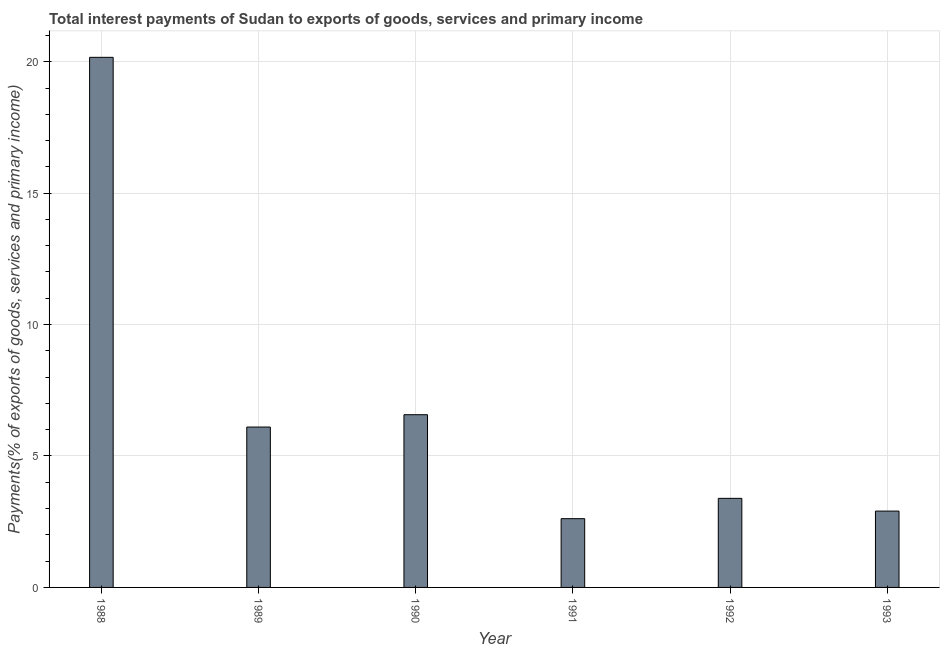Does the graph contain grids?
Offer a terse response. Yes. What is the title of the graph?
Provide a short and direct response. Total interest payments of Sudan to exports of goods, services and primary income. What is the label or title of the X-axis?
Offer a terse response. Year. What is the label or title of the Y-axis?
Your answer should be compact. Payments(% of exports of goods, services and primary income). What is the total interest payments on external debt in 1991?
Make the answer very short. 2.62. Across all years, what is the maximum total interest payments on external debt?
Offer a very short reply. 20.17. Across all years, what is the minimum total interest payments on external debt?
Provide a short and direct response. 2.62. In which year was the total interest payments on external debt maximum?
Provide a short and direct response. 1988. In which year was the total interest payments on external debt minimum?
Offer a terse response. 1991. What is the sum of the total interest payments on external debt?
Your answer should be very brief. 41.75. What is the difference between the total interest payments on external debt in 1990 and 1992?
Offer a very short reply. 3.18. What is the average total interest payments on external debt per year?
Your response must be concise. 6.96. What is the median total interest payments on external debt?
Your answer should be compact. 4.75. Do a majority of the years between 1990 and 1992 (inclusive) have total interest payments on external debt greater than 14 %?
Give a very brief answer. No. What is the ratio of the total interest payments on external debt in 1988 to that in 1989?
Your answer should be compact. 3.31. Is the total interest payments on external debt in 1988 less than that in 1990?
Make the answer very short. No. What is the difference between the highest and the second highest total interest payments on external debt?
Give a very brief answer. 13.6. Is the sum of the total interest payments on external debt in 1992 and 1993 greater than the maximum total interest payments on external debt across all years?
Give a very brief answer. No. What is the difference between the highest and the lowest total interest payments on external debt?
Give a very brief answer. 17.55. In how many years, is the total interest payments on external debt greater than the average total interest payments on external debt taken over all years?
Ensure brevity in your answer.  1. How many bars are there?
Ensure brevity in your answer.  6. Are all the bars in the graph horizontal?
Provide a short and direct response. No. What is the difference between two consecutive major ticks on the Y-axis?
Offer a very short reply. 5. What is the Payments(% of exports of goods, services and primary income) of 1988?
Offer a terse response. 20.17. What is the Payments(% of exports of goods, services and primary income) in 1989?
Your answer should be very brief. 6.1. What is the Payments(% of exports of goods, services and primary income) in 1990?
Provide a succinct answer. 6.57. What is the Payments(% of exports of goods, services and primary income) in 1991?
Ensure brevity in your answer.  2.62. What is the Payments(% of exports of goods, services and primary income) of 1992?
Offer a very short reply. 3.39. What is the Payments(% of exports of goods, services and primary income) of 1993?
Your answer should be very brief. 2.9. What is the difference between the Payments(% of exports of goods, services and primary income) in 1988 and 1989?
Provide a short and direct response. 14.07. What is the difference between the Payments(% of exports of goods, services and primary income) in 1988 and 1990?
Provide a short and direct response. 13.6. What is the difference between the Payments(% of exports of goods, services and primary income) in 1988 and 1991?
Offer a very short reply. 17.55. What is the difference between the Payments(% of exports of goods, services and primary income) in 1988 and 1992?
Your answer should be very brief. 16.78. What is the difference between the Payments(% of exports of goods, services and primary income) in 1988 and 1993?
Ensure brevity in your answer.  17.26. What is the difference between the Payments(% of exports of goods, services and primary income) in 1989 and 1990?
Give a very brief answer. -0.47. What is the difference between the Payments(% of exports of goods, services and primary income) in 1989 and 1991?
Provide a short and direct response. 3.49. What is the difference between the Payments(% of exports of goods, services and primary income) in 1989 and 1992?
Your answer should be very brief. 2.71. What is the difference between the Payments(% of exports of goods, services and primary income) in 1989 and 1993?
Your response must be concise. 3.2. What is the difference between the Payments(% of exports of goods, services and primary income) in 1990 and 1991?
Your answer should be very brief. 3.95. What is the difference between the Payments(% of exports of goods, services and primary income) in 1990 and 1992?
Offer a very short reply. 3.18. What is the difference between the Payments(% of exports of goods, services and primary income) in 1990 and 1993?
Your answer should be very brief. 3.67. What is the difference between the Payments(% of exports of goods, services and primary income) in 1991 and 1992?
Make the answer very short. -0.77. What is the difference between the Payments(% of exports of goods, services and primary income) in 1991 and 1993?
Provide a succinct answer. -0.29. What is the difference between the Payments(% of exports of goods, services and primary income) in 1992 and 1993?
Ensure brevity in your answer.  0.48. What is the ratio of the Payments(% of exports of goods, services and primary income) in 1988 to that in 1989?
Your answer should be very brief. 3.31. What is the ratio of the Payments(% of exports of goods, services and primary income) in 1988 to that in 1990?
Ensure brevity in your answer.  3.07. What is the ratio of the Payments(% of exports of goods, services and primary income) in 1988 to that in 1991?
Keep it short and to the point. 7.71. What is the ratio of the Payments(% of exports of goods, services and primary income) in 1988 to that in 1992?
Make the answer very short. 5.95. What is the ratio of the Payments(% of exports of goods, services and primary income) in 1988 to that in 1993?
Give a very brief answer. 6.94. What is the ratio of the Payments(% of exports of goods, services and primary income) in 1989 to that in 1990?
Make the answer very short. 0.93. What is the ratio of the Payments(% of exports of goods, services and primary income) in 1989 to that in 1991?
Give a very brief answer. 2.33. What is the ratio of the Payments(% of exports of goods, services and primary income) in 1989 to that in 1992?
Your answer should be compact. 1.8. What is the ratio of the Payments(% of exports of goods, services and primary income) in 1989 to that in 1993?
Give a very brief answer. 2.1. What is the ratio of the Payments(% of exports of goods, services and primary income) in 1990 to that in 1991?
Make the answer very short. 2.51. What is the ratio of the Payments(% of exports of goods, services and primary income) in 1990 to that in 1992?
Your answer should be very brief. 1.94. What is the ratio of the Payments(% of exports of goods, services and primary income) in 1990 to that in 1993?
Provide a short and direct response. 2.26. What is the ratio of the Payments(% of exports of goods, services and primary income) in 1991 to that in 1992?
Your response must be concise. 0.77. What is the ratio of the Payments(% of exports of goods, services and primary income) in 1991 to that in 1993?
Ensure brevity in your answer.  0.9. What is the ratio of the Payments(% of exports of goods, services and primary income) in 1992 to that in 1993?
Your answer should be compact. 1.17. 